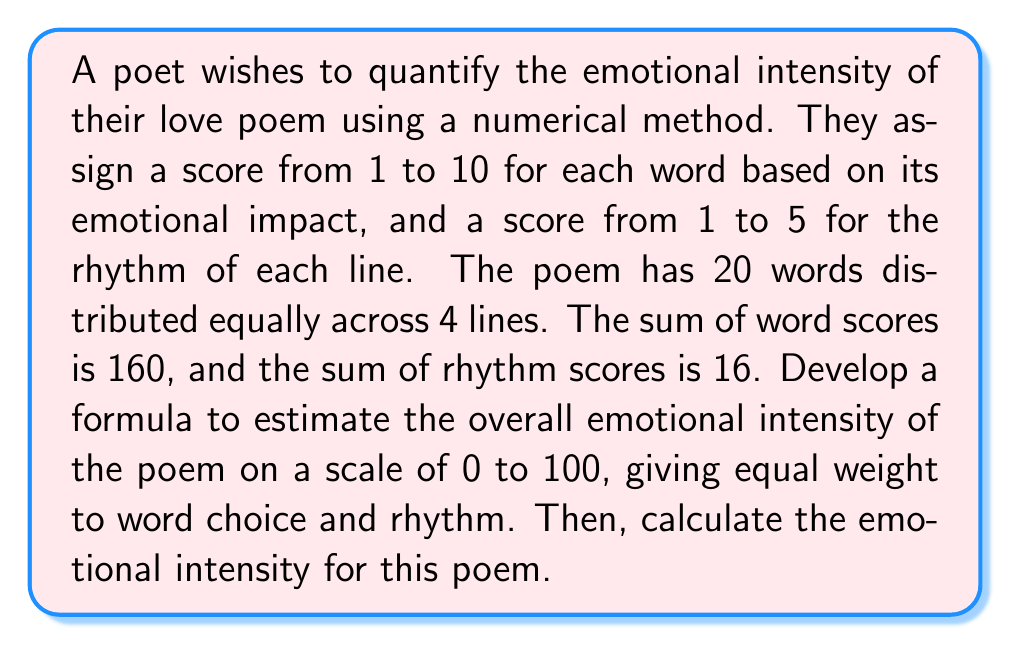Provide a solution to this math problem. To solve this problem, we'll follow these steps:

1) First, let's define our variables:
   $w$ = total word score
   $r$ = total rhythm score
   $n$ = number of words
   $l$ = number of lines

2) We need to normalize both word and rhythm scores to a 0-100 scale:

   For words: $\frac{w}{n \cdot 10} \cdot 100$ (since 10 is the max score per word)
   For rhythm: $\frac{r}{l \cdot 5} \cdot 100$ (since 5 is the max score per line)

3) As we want to give equal weight to word choice and rhythm, we'll take the average of these two normalized scores:

   $E = \frac{1}{2} \left(\frac{w}{n \cdot 10} \cdot 100 + \frac{r}{l \cdot 5} \cdot 100\right)$

4) Simplifying:

   $E = 50 \left(\frac{w}{n \cdot 10} + \frac{r}{l \cdot 5}\right)$

5) Now, let's plug in our known values:
   $w = 160$, $r = 16$, $n = 20$, $l = 4$

   $E = 50 \left(\frac{160}{20 \cdot 10} + \frac{16}{4 \cdot 5}\right)$

6) Simplifying:

   $E = 50 (0.8 + 0.8) = 50 \cdot 1.6 = 80$

Therefore, the emotional intensity of the poem is estimated to be 80 out of 100.
Answer: 80 